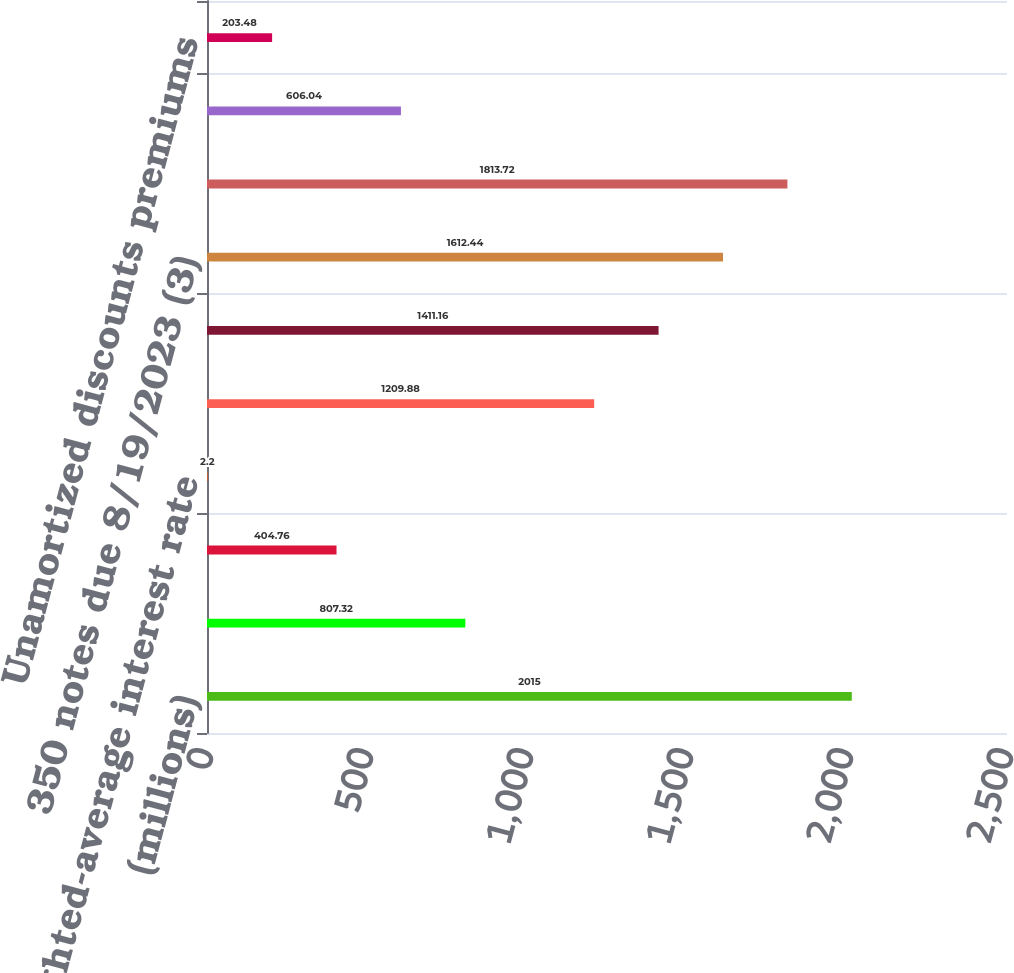Convert chart to OTSL. <chart><loc_0><loc_0><loc_500><loc_500><bar_chart><fcel>(millions)<fcel>Commercial paper<fcel>Other<fcel>Weighted-average interest rate<fcel>575 notes due 12/15/2017 (1)<fcel>390 notes due 7/8/2021 (2)<fcel>350 notes due 8/19/2023 (3)<fcel>325 notes due 11/15/2025 (4)<fcel>763-812 notes due 2024<fcel>Unamortized discounts premiums<nl><fcel>2015<fcel>807.32<fcel>404.76<fcel>2.2<fcel>1209.88<fcel>1411.16<fcel>1612.44<fcel>1813.72<fcel>606.04<fcel>203.48<nl></chart> 